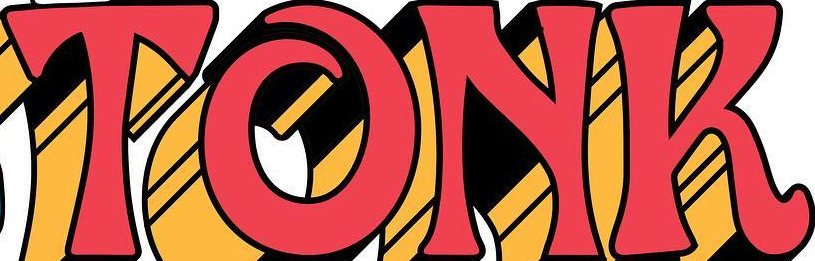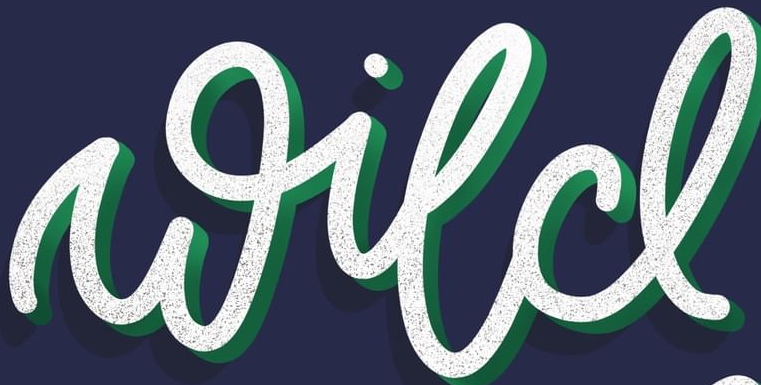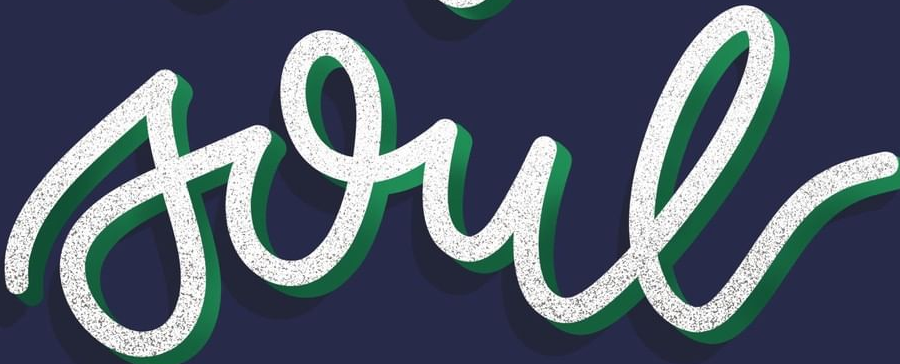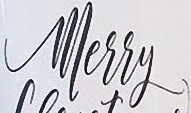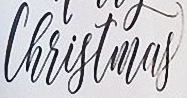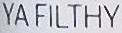Read the text content from these images in order, separated by a semicolon. TONK; wild; soul; Merry; Christmas; YAFILTHY 